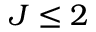<formula> <loc_0><loc_0><loc_500><loc_500>J \leq 2</formula> 